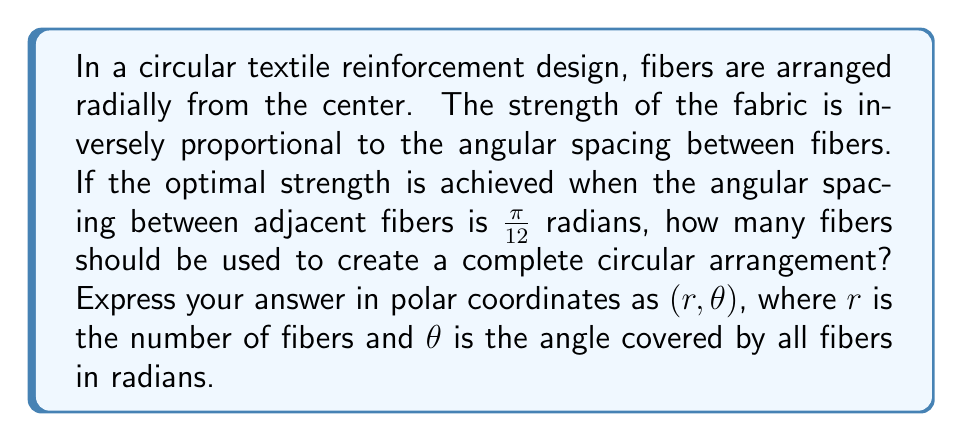What is the answer to this math problem? To solve this problem, we need to follow these steps:

1) First, recall that a complete circle spans $2\pi$ radians.

2) We're told that the optimal spacing between fibers is $\frac{\pi}{12}$ radians.

3) To find the number of fibers, we need to divide the total angle of the circle by the spacing between fibers:

   $$\text{Number of fibers} = \frac{\text{Total angle}}{\text{Spacing between fibers}} = \frac{2\pi}{\frac{\pi}{12}} = 2 \cdot 12 = 24$$

4) Now, we need to express this in polar coordinates. The number of fibers (24) will be our $r$ value.

5) For $\theta$, we need to calculate the total angle covered by all fibers. Since the fibers form a complete circle, this will always be $2\pi$ radians.

Therefore, our polar coordinate representation will be $(24, 2\pi)$.
Answer: $(24, 2\pi)$ 